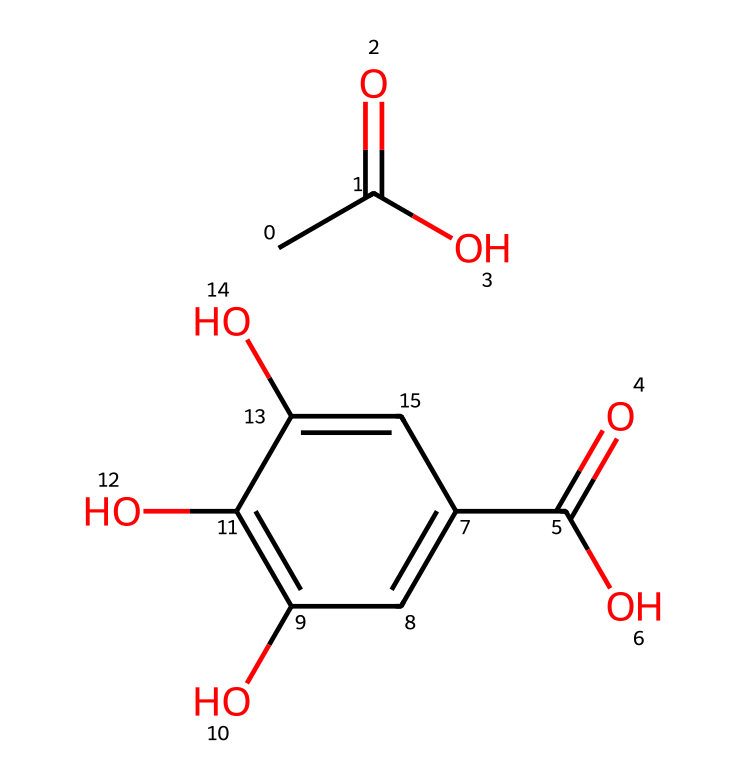what is the number of carbon atoms in this compound? By examining the SMILES representation, I identify the carbon atoms represented by "C" and the characters associated with the carbon structure. Counting all occurrences of "C", I find that there are a total of six carbon atoms.
Answer: six how many carboxylic acid functional groups are present? The SMILES notation shows two "C(=O)O" structures, indicating two distinct carboxylic acid groups within the compound.
Answer: two what type of chemical reaction might be involved in leather tanning with this compound? Leather tanning often involves cross-linking agents that bind collagen fibers in hides; thus, the presence of multiple functional groups in this compound suggests it could form ester or amide linkages through dehydration reactions.
Answer: cross-linking name one property that the hydroxyl groups in the compound contribute to leather properties. The hydroxyl groups (-OH) increase the compound's ability to form hydrogen bonds, which enhances the leather's flexibility and durability.
Answer: flexibility does this compound have aromatic rings? The presence of "c" in the SMILES notation indicates aromatic carbon atoms, confirming that the compound includes aromatic rings contributing to its stability and reactivity.
Answer: yes what might be the environmental impact of using this tanning compound? Some tanning agents, particularly those that are synthetic and contain heavy metals, can lead to environmental pollution; thus, the categorization of the components in this compound allows us to infer potential ecological effects.
Answer: pollution 